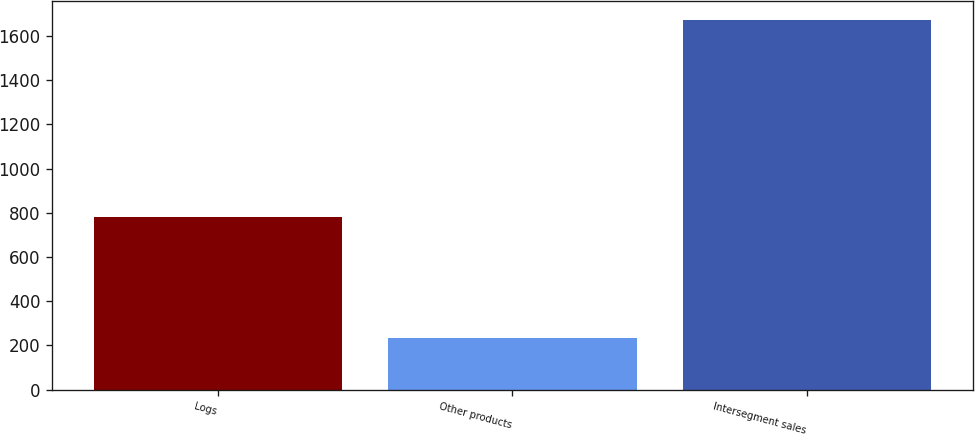Convert chart to OTSL. <chart><loc_0><loc_0><loc_500><loc_500><bar_chart><fcel>Logs<fcel>Other products<fcel>Intersegment sales<nl><fcel>781<fcel>235<fcel>1675<nl></chart> 